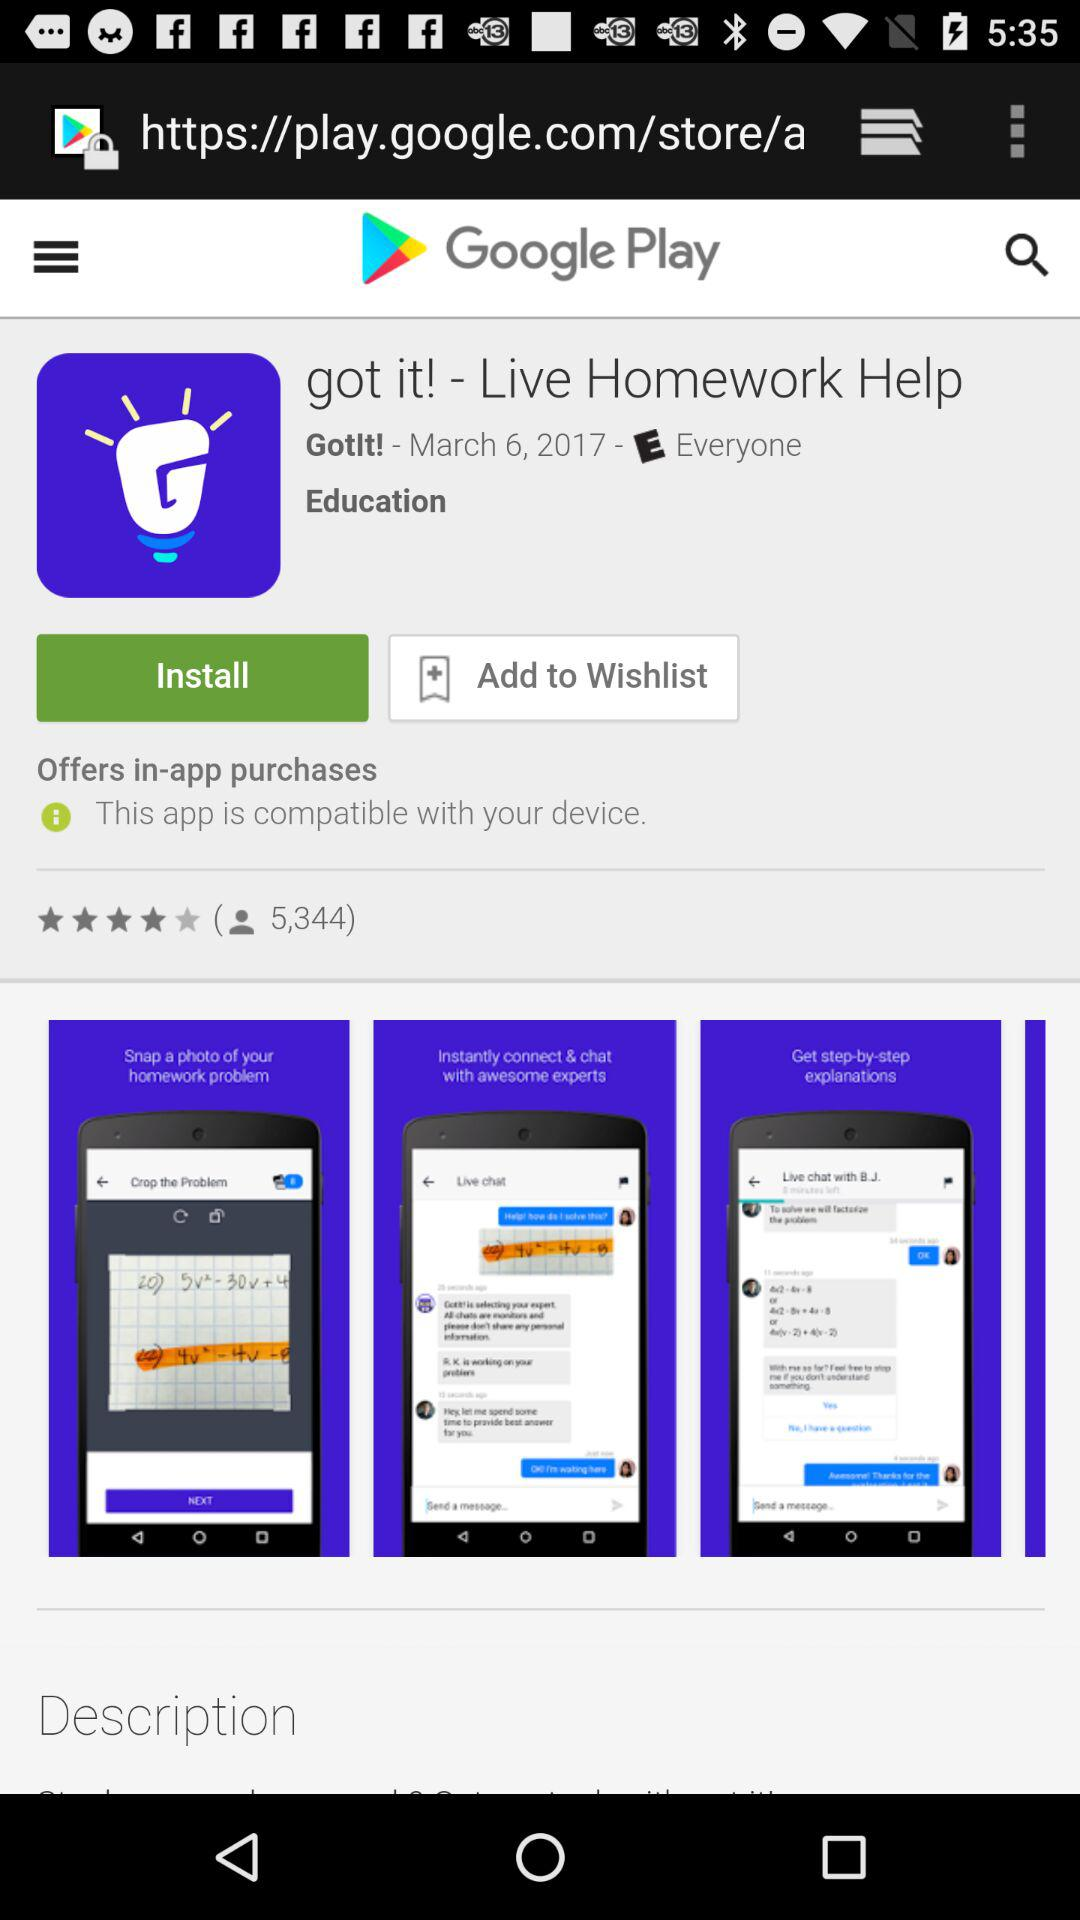How many rating are there for the application? There are 5,344 ratings. 